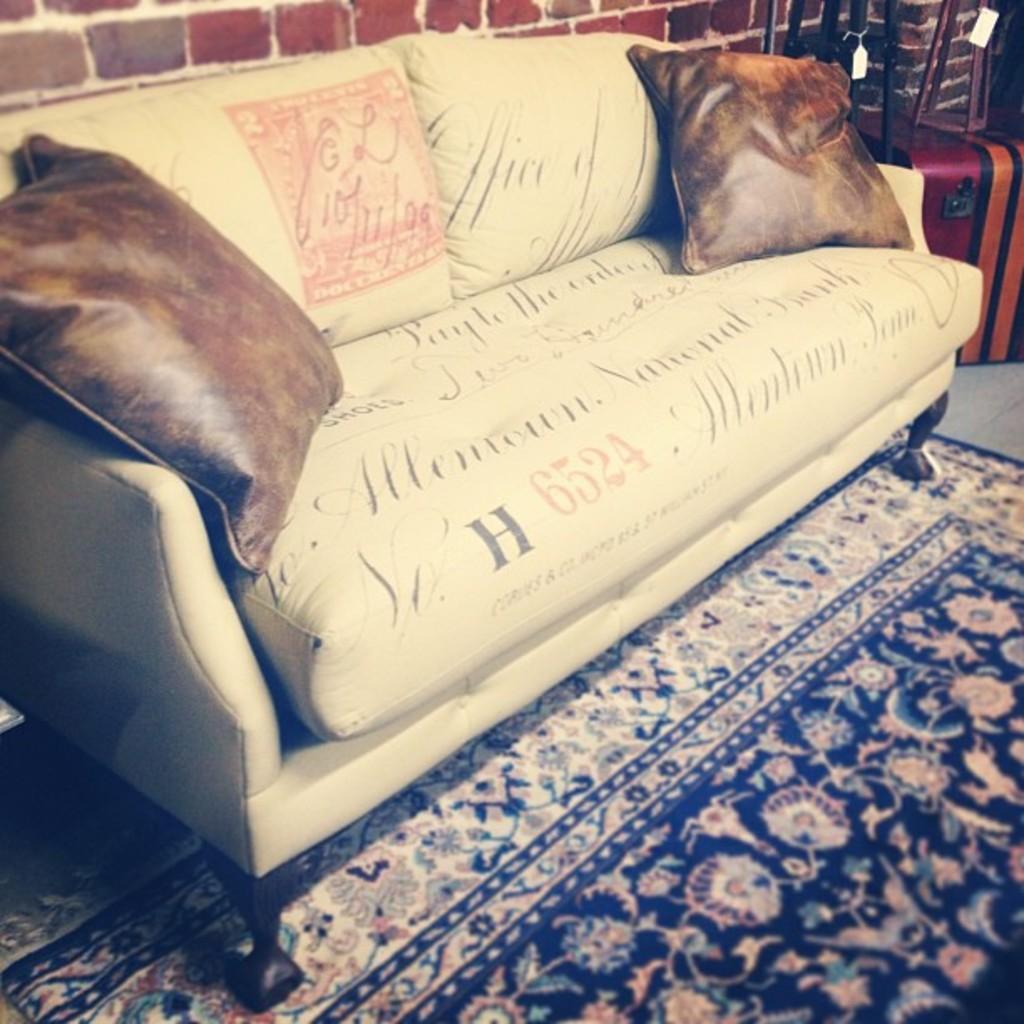Please provide a concise description of this image. In this picture we can see a sofa with pillows on it, carpet on the floor and in the background we can see the wall and some objects with tags. 